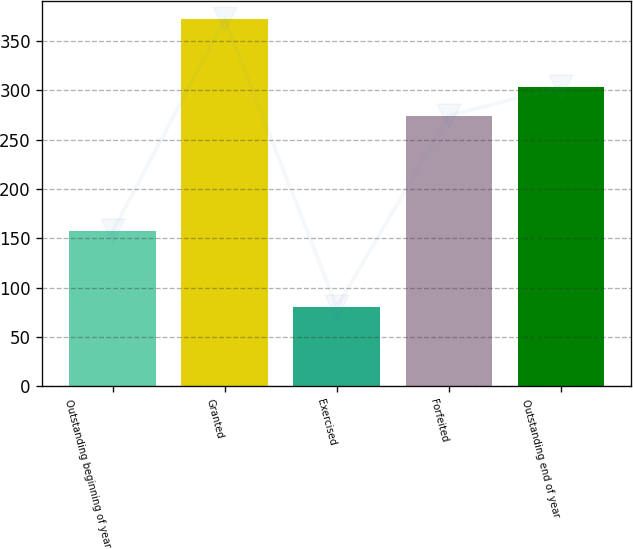Convert chart. <chart><loc_0><loc_0><loc_500><loc_500><bar_chart><fcel>Outstanding beginning of year<fcel>Granted<fcel>Exercised<fcel>Forfeited<fcel>Outstanding end of year<nl><fcel>157.07<fcel>371.7<fcel>80.31<fcel>274.25<fcel>303.39<nl></chart> 